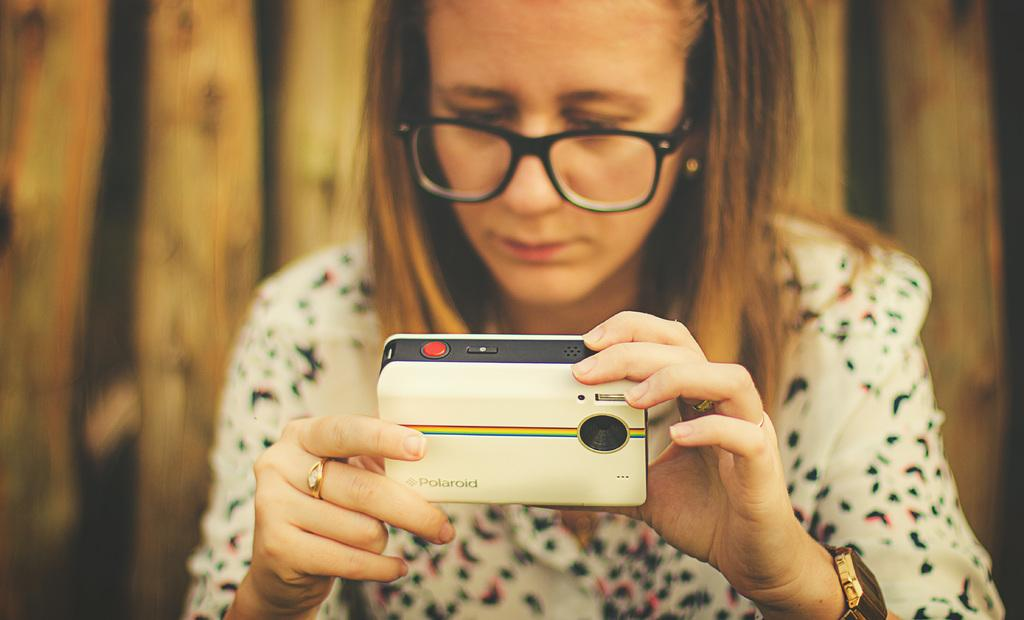What is the main subject of the image? The main subject of the image is a woman. What is the woman holding in her hands? The woman is holding a camera in her hands. Is the woman experiencing any pain in the image? There is no indication of pain in the image; the woman is simply holding a camera. Are there any worms visible in the image? There are no worms present in the image. 